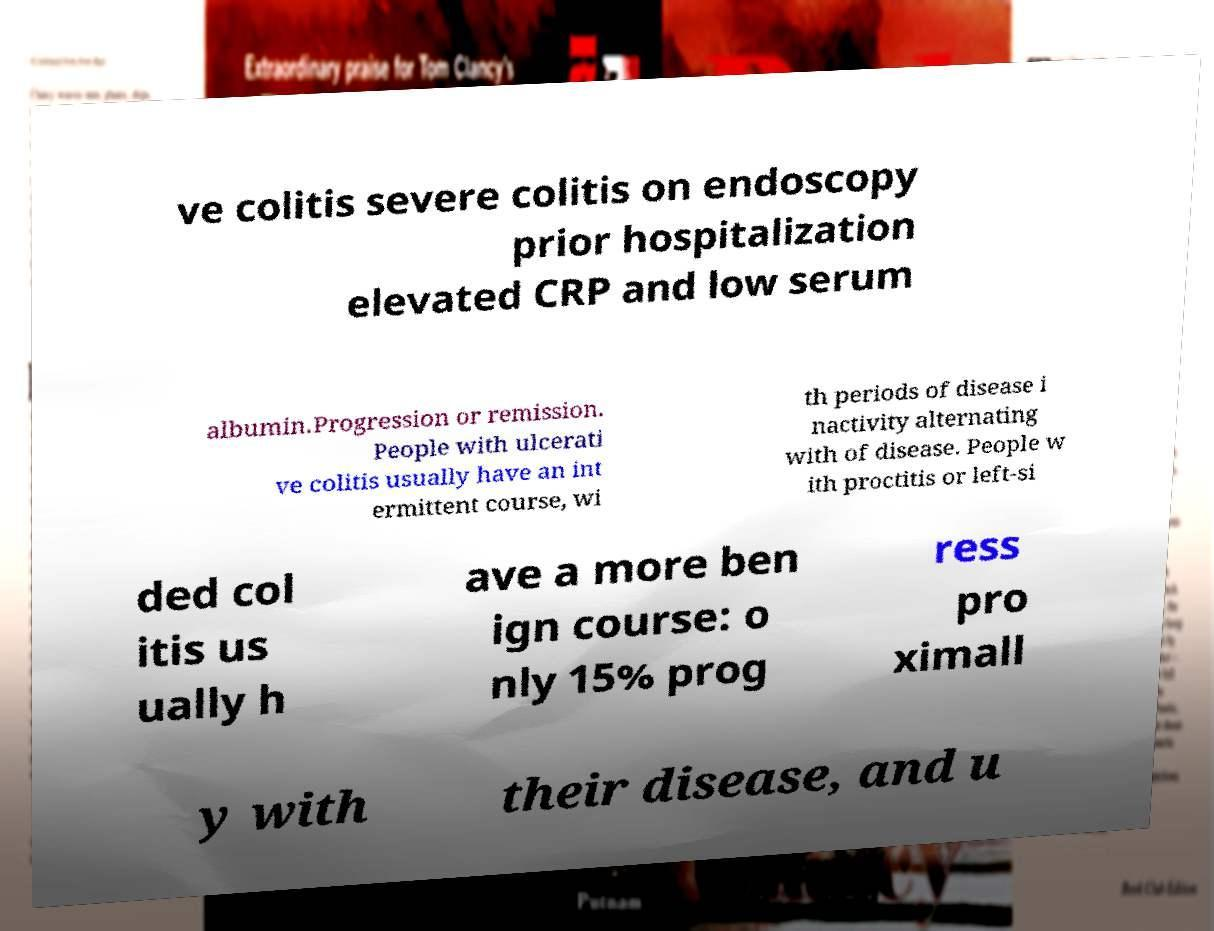There's text embedded in this image that I need extracted. Can you transcribe it verbatim? ve colitis severe colitis on endoscopy prior hospitalization elevated CRP and low serum albumin.Progression or remission. People with ulcerati ve colitis usually have an int ermittent course, wi th periods of disease i nactivity alternating with of disease. People w ith proctitis or left-si ded col itis us ually h ave a more ben ign course: o nly 15% prog ress pro ximall y with their disease, and u 